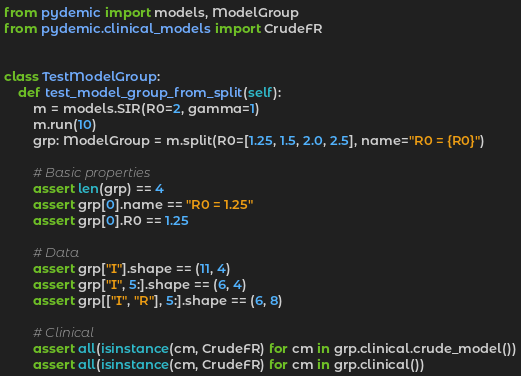Convert code to text. <code><loc_0><loc_0><loc_500><loc_500><_Python_>from pydemic import models, ModelGroup
from pydemic.clinical_models import CrudeFR


class TestModelGroup:
    def test_model_group_from_split(self):
        m = models.SIR(R0=2, gamma=1)
        m.run(10)
        grp: ModelGroup = m.split(R0=[1.25, 1.5, 2.0, 2.5], name="R0 = {R0}")

        # Basic properties
        assert len(grp) == 4
        assert grp[0].name == "R0 = 1.25"
        assert grp[0].R0 == 1.25

        # Data
        assert grp["I"].shape == (11, 4)
        assert grp["I", 5:].shape == (6, 4)
        assert grp[["I", "R"], 5:].shape == (6, 8)

        # Clinical
        assert all(isinstance(cm, CrudeFR) for cm in grp.clinical.crude_model())
        assert all(isinstance(cm, CrudeFR) for cm in grp.clinical())
</code> 